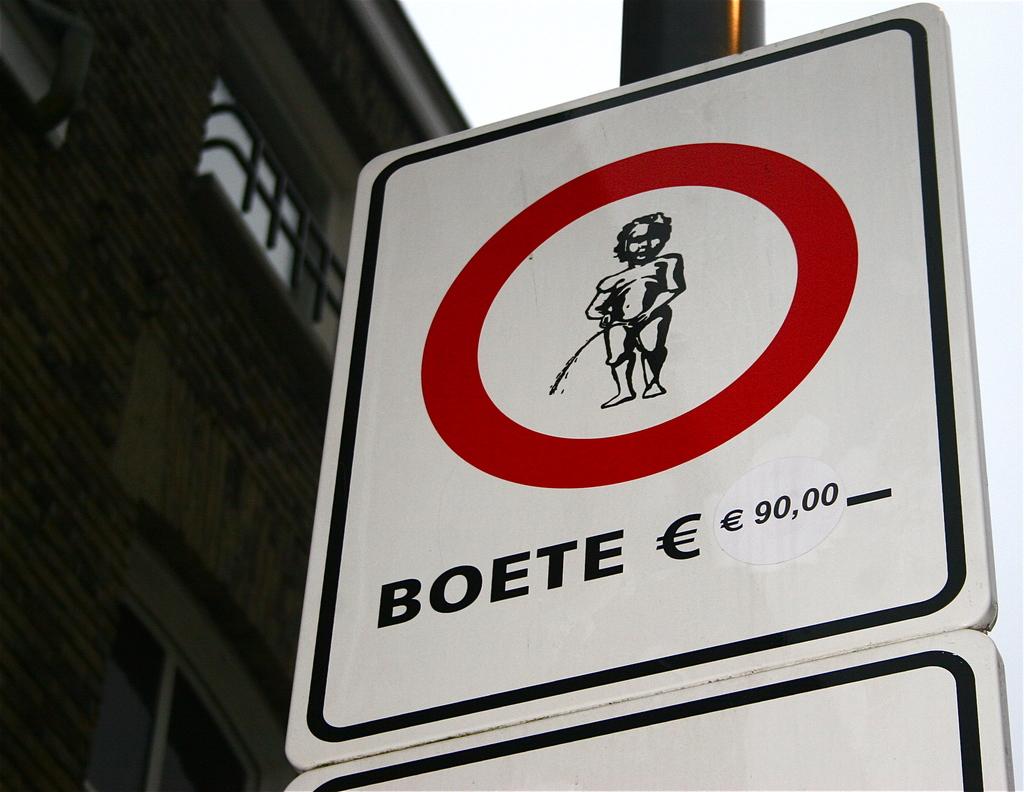What is the fine for children peeing?
Your answer should be compact. 90,00. 